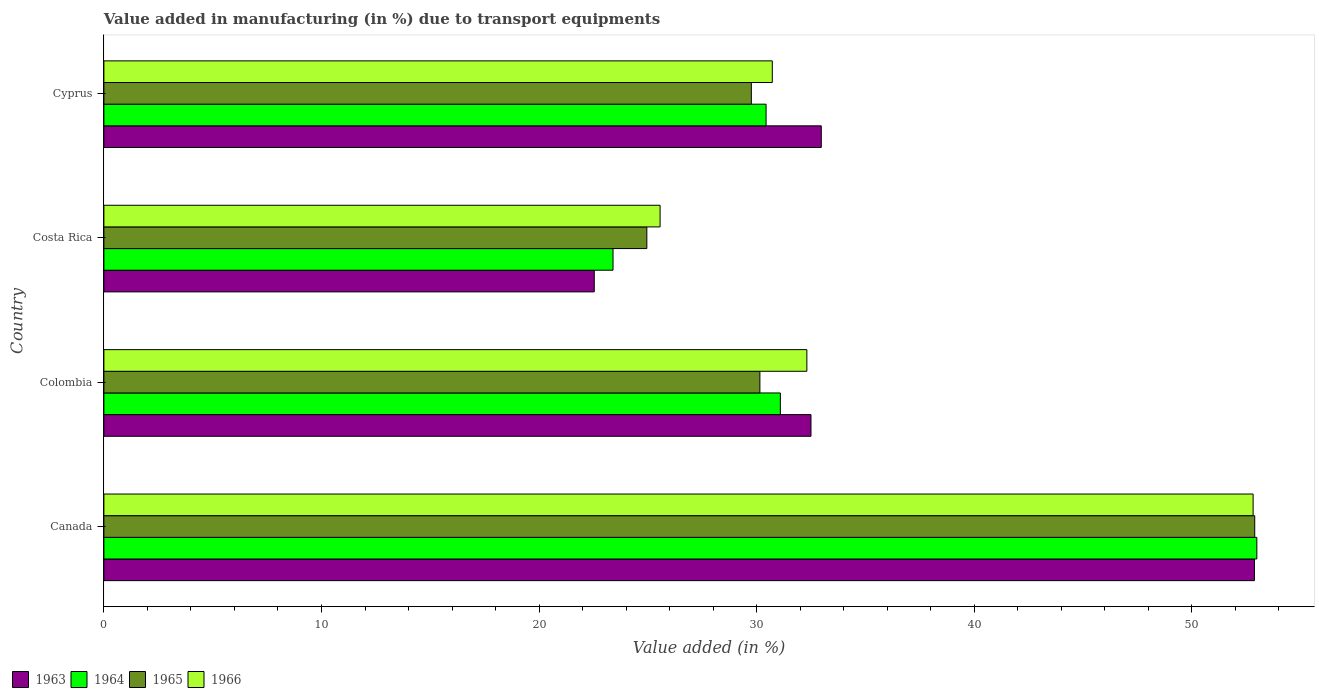How many different coloured bars are there?
Your answer should be very brief. 4. How many groups of bars are there?
Keep it short and to the point. 4. Are the number of bars per tick equal to the number of legend labels?
Give a very brief answer. Yes. How many bars are there on the 4th tick from the bottom?
Your answer should be very brief. 4. In how many cases, is the number of bars for a given country not equal to the number of legend labels?
Offer a very short reply. 0. What is the percentage of value added in manufacturing due to transport equipments in 1965 in Colombia?
Offer a terse response. 30.15. Across all countries, what is the maximum percentage of value added in manufacturing due to transport equipments in 1963?
Give a very brief answer. 52.87. Across all countries, what is the minimum percentage of value added in manufacturing due to transport equipments in 1963?
Offer a very short reply. 22.53. In which country was the percentage of value added in manufacturing due to transport equipments in 1964 minimum?
Your answer should be very brief. Costa Rica. What is the total percentage of value added in manufacturing due to transport equipments in 1966 in the graph?
Keep it short and to the point. 141.39. What is the difference between the percentage of value added in manufacturing due to transport equipments in 1966 in Colombia and that in Cyprus?
Provide a short and direct response. 1.59. What is the difference between the percentage of value added in manufacturing due to transport equipments in 1963 in Colombia and the percentage of value added in manufacturing due to transport equipments in 1965 in Canada?
Keep it short and to the point. -20.39. What is the average percentage of value added in manufacturing due to transport equipments in 1965 per country?
Provide a short and direct response. 34.43. What is the difference between the percentage of value added in manufacturing due to transport equipments in 1963 and percentage of value added in manufacturing due to transport equipments in 1964 in Cyprus?
Give a very brief answer. 2.54. In how many countries, is the percentage of value added in manufacturing due to transport equipments in 1964 greater than 44 %?
Provide a succinct answer. 1. What is the ratio of the percentage of value added in manufacturing due to transport equipments in 1966 in Costa Rica to that in Cyprus?
Provide a succinct answer. 0.83. Is the percentage of value added in manufacturing due to transport equipments in 1965 in Costa Rica less than that in Cyprus?
Give a very brief answer. Yes. What is the difference between the highest and the second highest percentage of value added in manufacturing due to transport equipments in 1963?
Make the answer very short. 19.91. What is the difference between the highest and the lowest percentage of value added in manufacturing due to transport equipments in 1964?
Make the answer very short. 29.59. In how many countries, is the percentage of value added in manufacturing due to transport equipments in 1964 greater than the average percentage of value added in manufacturing due to transport equipments in 1964 taken over all countries?
Make the answer very short. 1. What does the 3rd bar from the top in Canada represents?
Your answer should be compact. 1964. Is it the case that in every country, the sum of the percentage of value added in manufacturing due to transport equipments in 1965 and percentage of value added in manufacturing due to transport equipments in 1963 is greater than the percentage of value added in manufacturing due to transport equipments in 1964?
Ensure brevity in your answer.  Yes. How many bars are there?
Your response must be concise. 16. Are all the bars in the graph horizontal?
Give a very brief answer. Yes. How many countries are there in the graph?
Make the answer very short. 4. Are the values on the major ticks of X-axis written in scientific E-notation?
Provide a short and direct response. No. Does the graph contain any zero values?
Provide a succinct answer. No. Does the graph contain grids?
Provide a succinct answer. No. Where does the legend appear in the graph?
Offer a very short reply. Bottom left. How many legend labels are there?
Your answer should be compact. 4. How are the legend labels stacked?
Make the answer very short. Horizontal. What is the title of the graph?
Give a very brief answer. Value added in manufacturing (in %) due to transport equipments. What is the label or title of the X-axis?
Offer a terse response. Value added (in %). What is the Value added (in %) of 1963 in Canada?
Your answer should be very brief. 52.87. What is the Value added (in %) of 1964 in Canada?
Your response must be concise. 52.98. What is the Value added (in %) in 1965 in Canada?
Provide a short and direct response. 52.89. What is the Value added (in %) in 1966 in Canada?
Your response must be concise. 52.81. What is the Value added (in %) in 1963 in Colombia?
Ensure brevity in your answer.  32.49. What is the Value added (in %) of 1964 in Colombia?
Offer a very short reply. 31.09. What is the Value added (in %) of 1965 in Colombia?
Your answer should be very brief. 30.15. What is the Value added (in %) of 1966 in Colombia?
Your answer should be very brief. 32.3. What is the Value added (in %) of 1963 in Costa Rica?
Make the answer very short. 22.53. What is the Value added (in %) in 1964 in Costa Rica?
Ensure brevity in your answer.  23.4. What is the Value added (in %) in 1965 in Costa Rica?
Offer a terse response. 24.95. What is the Value added (in %) in 1966 in Costa Rica?
Offer a very short reply. 25.56. What is the Value added (in %) in 1963 in Cyprus?
Offer a terse response. 32.97. What is the Value added (in %) of 1964 in Cyprus?
Keep it short and to the point. 30.43. What is the Value added (in %) of 1965 in Cyprus?
Provide a short and direct response. 29.75. What is the Value added (in %) in 1966 in Cyprus?
Provide a short and direct response. 30.72. Across all countries, what is the maximum Value added (in %) in 1963?
Your response must be concise. 52.87. Across all countries, what is the maximum Value added (in %) in 1964?
Your answer should be very brief. 52.98. Across all countries, what is the maximum Value added (in %) of 1965?
Your response must be concise. 52.89. Across all countries, what is the maximum Value added (in %) of 1966?
Offer a terse response. 52.81. Across all countries, what is the minimum Value added (in %) in 1963?
Your answer should be very brief. 22.53. Across all countries, what is the minimum Value added (in %) in 1964?
Your answer should be very brief. 23.4. Across all countries, what is the minimum Value added (in %) of 1965?
Offer a very short reply. 24.95. Across all countries, what is the minimum Value added (in %) in 1966?
Provide a short and direct response. 25.56. What is the total Value added (in %) of 1963 in the graph?
Give a very brief answer. 140.87. What is the total Value added (in %) of 1964 in the graph?
Keep it short and to the point. 137.89. What is the total Value added (in %) in 1965 in the graph?
Provide a short and direct response. 137.73. What is the total Value added (in %) in 1966 in the graph?
Give a very brief answer. 141.39. What is the difference between the Value added (in %) in 1963 in Canada and that in Colombia?
Ensure brevity in your answer.  20.38. What is the difference between the Value added (in %) in 1964 in Canada and that in Colombia?
Give a very brief answer. 21.9. What is the difference between the Value added (in %) in 1965 in Canada and that in Colombia?
Your answer should be compact. 22.74. What is the difference between the Value added (in %) of 1966 in Canada and that in Colombia?
Give a very brief answer. 20.51. What is the difference between the Value added (in %) in 1963 in Canada and that in Costa Rica?
Keep it short and to the point. 30.34. What is the difference between the Value added (in %) in 1964 in Canada and that in Costa Rica?
Offer a very short reply. 29.59. What is the difference between the Value added (in %) in 1965 in Canada and that in Costa Rica?
Provide a short and direct response. 27.93. What is the difference between the Value added (in %) in 1966 in Canada and that in Costa Rica?
Provide a short and direct response. 27.25. What is the difference between the Value added (in %) in 1963 in Canada and that in Cyprus?
Ensure brevity in your answer.  19.91. What is the difference between the Value added (in %) of 1964 in Canada and that in Cyprus?
Make the answer very short. 22.55. What is the difference between the Value added (in %) in 1965 in Canada and that in Cyprus?
Your response must be concise. 23.13. What is the difference between the Value added (in %) in 1966 in Canada and that in Cyprus?
Your answer should be compact. 22.1. What is the difference between the Value added (in %) of 1963 in Colombia and that in Costa Rica?
Make the answer very short. 9.96. What is the difference between the Value added (in %) in 1964 in Colombia and that in Costa Rica?
Offer a very short reply. 7.69. What is the difference between the Value added (in %) of 1965 in Colombia and that in Costa Rica?
Your answer should be compact. 5.2. What is the difference between the Value added (in %) of 1966 in Colombia and that in Costa Rica?
Provide a short and direct response. 6.74. What is the difference between the Value added (in %) in 1963 in Colombia and that in Cyprus?
Offer a terse response. -0.47. What is the difference between the Value added (in %) of 1964 in Colombia and that in Cyprus?
Give a very brief answer. 0.66. What is the difference between the Value added (in %) of 1965 in Colombia and that in Cyprus?
Provide a succinct answer. 0.39. What is the difference between the Value added (in %) of 1966 in Colombia and that in Cyprus?
Your response must be concise. 1.59. What is the difference between the Value added (in %) in 1963 in Costa Rica and that in Cyprus?
Provide a succinct answer. -10.43. What is the difference between the Value added (in %) of 1964 in Costa Rica and that in Cyprus?
Provide a succinct answer. -7.03. What is the difference between the Value added (in %) of 1965 in Costa Rica and that in Cyprus?
Provide a succinct answer. -4.8. What is the difference between the Value added (in %) in 1966 in Costa Rica and that in Cyprus?
Offer a terse response. -5.16. What is the difference between the Value added (in %) of 1963 in Canada and the Value added (in %) of 1964 in Colombia?
Your response must be concise. 21.79. What is the difference between the Value added (in %) of 1963 in Canada and the Value added (in %) of 1965 in Colombia?
Keep it short and to the point. 22.73. What is the difference between the Value added (in %) in 1963 in Canada and the Value added (in %) in 1966 in Colombia?
Your response must be concise. 20.57. What is the difference between the Value added (in %) of 1964 in Canada and the Value added (in %) of 1965 in Colombia?
Keep it short and to the point. 22.84. What is the difference between the Value added (in %) in 1964 in Canada and the Value added (in %) in 1966 in Colombia?
Offer a very short reply. 20.68. What is the difference between the Value added (in %) in 1965 in Canada and the Value added (in %) in 1966 in Colombia?
Provide a succinct answer. 20.58. What is the difference between the Value added (in %) in 1963 in Canada and the Value added (in %) in 1964 in Costa Rica?
Provide a succinct answer. 29.48. What is the difference between the Value added (in %) in 1963 in Canada and the Value added (in %) in 1965 in Costa Rica?
Offer a terse response. 27.92. What is the difference between the Value added (in %) in 1963 in Canada and the Value added (in %) in 1966 in Costa Rica?
Your answer should be very brief. 27.31. What is the difference between the Value added (in %) of 1964 in Canada and the Value added (in %) of 1965 in Costa Rica?
Offer a terse response. 28.03. What is the difference between the Value added (in %) of 1964 in Canada and the Value added (in %) of 1966 in Costa Rica?
Your answer should be compact. 27.42. What is the difference between the Value added (in %) of 1965 in Canada and the Value added (in %) of 1966 in Costa Rica?
Offer a very short reply. 27.33. What is the difference between the Value added (in %) in 1963 in Canada and the Value added (in %) in 1964 in Cyprus?
Provide a short and direct response. 22.44. What is the difference between the Value added (in %) in 1963 in Canada and the Value added (in %) in 1965 in Cyprus?
Give a very brief answer. 23.12. What is the difference between the Value added (in %) in 1963 in Canada and the Value added (in %) in 1966 in Cyprus?
Make the answer very short. 22.16. What is the difference between the Value added (in %) of 1964 in Canada and the Value added (in %) of 1965 in Cyprus?
Your response must be concise. 23.23. What is the difference between the Value added (in %) in 1964 in Canada and the Value added (in %) in 1966 in Cyprus?
Your answer should be compact. 22.27. What is the difference between the Value added (in %) in 1965 in Canada and the Value added (in %) in 1966 in Cyprus?
Offer a very short reply. 22.17. What is the difference between the Value added (in %) in 1963 in Colombia and the Value added (in %) in 1964 in Costa Rica?
Your answer should be very brief. 9.1. What is the difference between the Value added (in %) in 1963 in Colombia and the Value added (in %) in 1965 in Costa Rica?
Offer a terse response. 7.54. What is the difference between the Value added (in %) in 1963 in Colombia and the Value added (in %) in 1966 in Costa Rica?
Give a very brief answer. 6.93. What is the difference between the Value added (in %) in 1964 in Colombia and the Value added (in %) in 1965 in Costa Rica?
Offer a very short reply. 6.14. What is the difference between the Value added (in %) of 1964 in Colombia and the Value added (in %) of 1966 in Costa Rica?
Your answer should be very brief. 5.53. What is the difference between the Value added (in %) in 1965 in Colombia and the Value added (in %) in 1966 in Costa Rica?
Make the answer very short. 4.59. What is the difference between the Value added (in %) in 1963 in Colombia and the Value added (in %) in 1964 in Cyprus?
Make the answer very short. 2.06. What is the difference between the Value added (in %) in 1963 in Colombia and the Value added (in %) in 1965 in Cyprus?
Give a very brief answer. 2.74. What is the difference between the Value added (in %) of 1963 in Colombia and the Value added (in %) of 1966 in Cyprus?
Provide a succinct answer. 1.78. What is the difference between the Value added (in %) in 1964 in Colombia and the Value added (in %) in 1965 in Cyprus?
Give a very brief answer. 1.33. What is the difference between the Value added (in %) in 1964 in Colombia and the Value added (in %) in 1966 in Cyprus?
Ensure brevity in your answer.  0.37. What is the difference between the Value added (in %) in 1965 in Colombia and the Value added (in %) in 1966 in Cyprus?
Make the answer very short. -0.57. What is the difference between the Value added (in %) in 1963 in Costa Rica and the Value added (in %) in 1964 in Cyprus?
Keep it short and to the point. -7.9. What is the difference between the Value added (in %) of 1963 in Costa Rica and the Value added (in %) of 1965 in Cyprus?
Your response must be concise. -7.22. What is the difference between the Value added (in %) in 1963 in Costa Rica and the Value added (in %) in 1966 in Cyprus?
Provide a succinct answer. -8.18. What is the difference between the Value added (in %) in 1964 in Costa Rica and the Value added (in %) in 1965 in Cyprus?
Your answer should be very brief. -6.36. What is the difference between the Value added (in %) of 1964 in Costa Rica and the Value added (in %) of 1966 in Cyprus?
Keep it short and to the point. -7.32. What is the difference between the Value added (in %) in 1965 in Costa Rica and the Value added (in %) in 1966 in Cyprus?
Make the answer very short. -5.77. What is the average Value added (in %) of 1963 per country?
Offer a terse response. 35.22. What is the average Value added (in %) in 1964 per country?
Offer a terse response. 34.47. What is the average Value added (in %) of 1965 per country?
Provide a short and direct response. 34.43. What is the average Value added (in %) in 1966 per country?
Give a very brief answer. 35.35. What is the difference between the Value added (in %) of 1963 and Value added (in %) of 1964 in Canada?
Ensure brevity in your answer.  -0.11. What is the difference between the Value added (in %) of 1963 and Value added (in %) of 1965 in Canada?
Give a very brief answer. -0.01. What is the difference between the Value added (in %) of 1963 and Value added (in %) of 1966 in Canada?
Give a very brief answer. 0.06. What is the difference between the Value added (in %) in 1964 and Value added (in %) in 1965 in Canada?
Your response must be concise. 0.1. What is the difference between the Value added (in %) of 1964 and Value added (in %) of 1966 in Canada?
Ensure brevity in your answer.  0.17. What is the difference between the Value added (in %) of 1965 and Value added (in %) of 1966 in Canada?
Your response must be concise. 0.07. What is the difference between the Value added (in %) in 1963 and Value added (in %) in 1964 in Colombia?
Offer a very short reply. 1.41. What is the difference between the Value added (in %) of 1963 and Value added (in %) of 1965 in Colombia?
Ensure brevity in your answer.  2.35. What is the difference between the Value added (in %) of 1963 and Value added (in %) of 1966 in Colombia?
Give a very brief answer. 0.19. What is the difference between the Value added (in %) of 1964 and Value added (in %) of 1965 in Colombia?
Your response must be concise. 0.94. What is the difference between the Value added (in %) in 1964 and Value added (in %) in 1966 in Colombia?
Your answer should be compact. -1.22. What is the difference between the Value added (in %) in 1965 and Value added (in %) in 1966 in Colombia?
Provide a short and direct response. -2.16. What is the difference between the Value added (in %) of 1963 and Value added (in %) of 1964 in Costa Rica?
Provide a succinct answer. -0.86. What is the difference between the Value added (in %) in 1963 and Value added (in %) in 1965 in Costa Rica?
Make the answer very short. -2.42. What is the difference between the Value added (in %) of 1963 and Value added (in %) of 1966 in Costa Rica?
Ensure brevity in your answer.  -3.03. What is the difference between the Value added (in %) in 1964 and Value added (in %) in 1965 in Costa Rica?
Your answer should be compact. -1.55. What is the difference between the Value added (in %) in 1964 and Value added (in %) in 1966 in Costa Rica?
Your answer should be very brief. -2.16. What is the difference between the Value added (in %) in 1965 and Value added (in %) in 1966 in Costa Rica?
Your answer should be compact. -0.61. What is the difference between the Value added (in %) of 1963 and Value added (in %) of 1964 in Cyprus?
Your answer should be very brief. 2.54. What is the difference between the Value added (in %) of 1963 and Value added (in %) of 1965 in Cyprus?
Keep it short and to the point. 3.21. What is the difference between the Value added (in %) in 1963 and Value added (in %) in 1966 in Cyprus?
Ensure brevity in your answer.  2.25. What is the difference between the Value added (in %) of 1964 and Value added (in %) of 1965 in Cyprus?
Provide a succinct answer. 0.68. What is the difference between the Value added (in %) in 1964 and Value added (in %) in 1966 in Cyprus?
Ensure brevity in your answer.  -0.29. What is the difference between the Value added (in %) in 1965 and Value added (in %) in 1966 in Cyprus?
Give a very brief answer. -0.96. What is the ratio of the Value added (in %) of 1963 in Canada to that in Colombia?
Keep it short and to the point. 1.63. What is the ratio of the Value added (in %) of 1964 in Canada to that in Colombia?
Provide a short and direct response. 1.7. What is the ratio of the Value added (in %) of 1965 in Canada to that in Colombia?
Provide a short and direct response. 1.75. What is the ratio of the Value added (in %) in 1966 in Canada to that in Colombia?
Provide a succinct answer. 1.63. What is the ratio of the Value added (in %) in 1963 in Canada to that in Costa Rica?
Provide a succinct answer. 2.35. What is the ratio of the Value added (in %) of 1964 in Canada to that in Costa Rica?
Provide a short and direct response. 2.26. What is the ratio of the Value added (in %) in 1965 in Canada to that in Costa Rica?
Keep it short and to the point. 2.12. What is the ratio of the Value added (in %) of 1966 in Canada to that in Costa Rica?
Your response must be concise. 2.07. What is the ratio of the Value added (in %) of 1963 in Canada to that in Cyprus?
Give a very brief answer. 1.6. What is the ratio of the Value added (in %) of 1964 in Canada to that in Cyprus?
Make the answer very short. 1.74. What is the ratio of the Value added (in %) of 1965 in Canada to that in Cyprus?
Give a very brief answer. 1.78. What is the ratio of the Value added (in %) in 1966 in Canada to that in Cyprus?
Offer a terse response. 1.72. What is the ratio of the Value added (in %) in 1963 in Colombia to that in Costa Rica?
Provide a short and direct response. 1.44. What is the ratio of the Value added (in %) in 1964 in Colombia to that in Costa Rica?
Offer a terse response. 1.33. What is the ratio of the Value added (in %) of 1965 in Colombia to that in Costa Rica?
Your answer should be compact. 1.21. What is the ratio of the Value added (in %) of 1966 in Colombia to that in Costa Rica?
Give a very brief answer. 1.26. What is the ratio of the Value added (in %) of 1963 in Colombia to that in Cyprus?
Your answer should be very brief. 0.99. What is the ratio of the Value added (in %) in 1964 in Colombia to that in Cyprus?
Your answer should be compact. 1.02. What is the ratio of the Value added (in %) of 1965 in Colombia to that in Cyprus?
Your answer should be very brief. 1.01. What is the ratio of the Value added (in %) of 1966 in Colombia to that in Cyprus?
Offer a very short reply. 1.05. What is the ratio of the Value added (in %) of 1963 in Costa Rica to that in Cyprus?
Provide a short and direct response. 0.68. What is the ratio of the Value added (in %) of 1964 in Costa Rica to that in Cyprus?
Keep it short and to the point. 0.77. What is the ratio of the Value added (in %) in 1965 in Costa Rica to that in Cyprus?
Give a very brief answer. 0.84. What is the ratio of the Value added (in %) of 1966 in Costa Rica to that in Cyprus?
Provide a succinct answer. 0.83. What is the difference between the highest and the second highest Value added (in %) in 1963?
Your response must be concise. 19.91. What is the difference between the highest and the second highest Value added (in %) in 1964?
Your response must be concise. 21.9. What is the difference between the highest and the second highest Value added (in %) in 1965?
Your response must be concise. 22.74. What is the difference between the highest and the second highest Value added (in %) of 1966?
Offer a very short reply. 20.51. What is the difference between the highest and the lowest Value added (in %) of 1963?
Your answer should be compact. 30.34. What is the difference between the highest and the lowest Value added (in %) of 1964?
Your answer should be compact. 29.59. What is the difference between the highest and the lowest Value added (in %) in 1965?
Give a very brief answer. 27.93. What is the difference between the highest and the lowest Value added (in %) in 1966?
Ensure brevity in your answer.  27.25. 